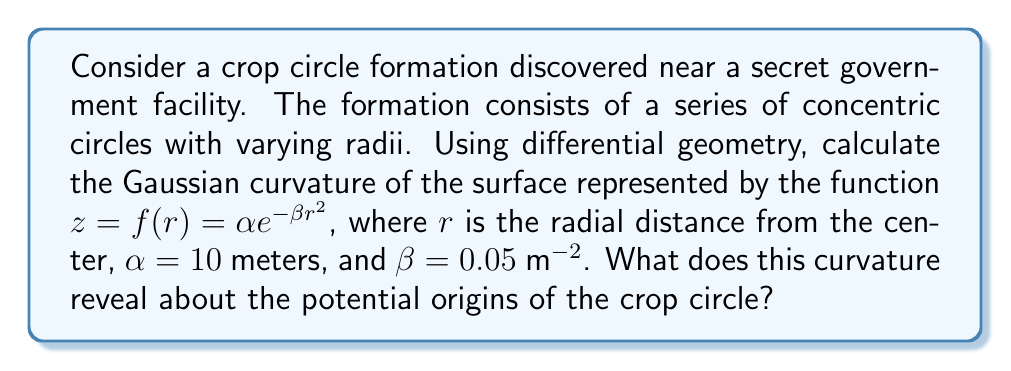Provide a solution to this math problem. To analyze the geometric patterns in the crop circle using differential geometry, we'll calculate the Gaussian curvature of the surface described by the given function.

1. The surface is described by $z = f(r) = \alpha e^{-\beta r^2}$, where $\alpha = 10$ m and $\beta = 0.05$ m^(-2).

2. In cylindrical coordinates, the surface can be parameterized as:
   $x = r \cos\theta$
   $y = r \sin\theta$
   $z = \alpha e^{-\beta r^2}$

3. To calculate the Gaussian curvature, we need to find the coefficients of the first and second fundamental forms:

   $E = 1 + (f'(r))^2$
   $F = 0$
   $G = r^2$
   
   $L = -f''(r)$
   $M = 0$
   $N = \frac{rf'(r)}{\sqrt{1+(f'(r))^2}}$

4. Calculate $f'(r)$ and $f''(r)$:
   $f'(r) = -2\alpha\beta r e^{-\beta r^2}$
   $f''(r) = -2\alpha\beta e^{-\beta r^2} + 4\alpha\beta^2 r^2 e^{-\beta r^2}$

5. The Gaussian curvature is given by:
   $$K = \frac{LN - M^2}{EG - F^2}$$

6. Substituting the values:
   $$K = \frac{(-f''(r))(\frac{rf'(r)}{\sqrt{1+(f'(r))^2}}) - 0^2}{(1 + (f'(r))^2)(r^2) - 0^2}$$

7. Simplify and substitute the expressions for $f'(r)$ and $f''(r)$:
   $$K = \frac{2\alpha\beta e^{-\beta r^2}(1 - 2\beta r^2)}{r(1 + 4\alpha^2\beta^2 r^2 e^{-2\beta r^2})}$$

8. Substitute the given values $\alpha = 10$ m and $\beta = 0.05$ m^(-2):
   $$K = \frac{e^{-0.05r^2}(1 - 0.1r^2)}{r(1 + 100r^2 e^{-0.1r^2})}$$

This expression gives the Gaussian curvature as a function of the radial distance $r$ from the center of the crop circle.
Answer: The Gaussian curvature of the surface is given by:
$$K = \frac{e^{-0.05r^2}(1 - 0.1r^2)}{r(1 + 100r^2 e^{-0.1r^2})}$$
This non-uniform curvature suggests a complex geometric pattern that would be difficult to create using conventional agricultural equipment, potentially supporting theories of non-human or advanced technological origins for the crop circle formation. 